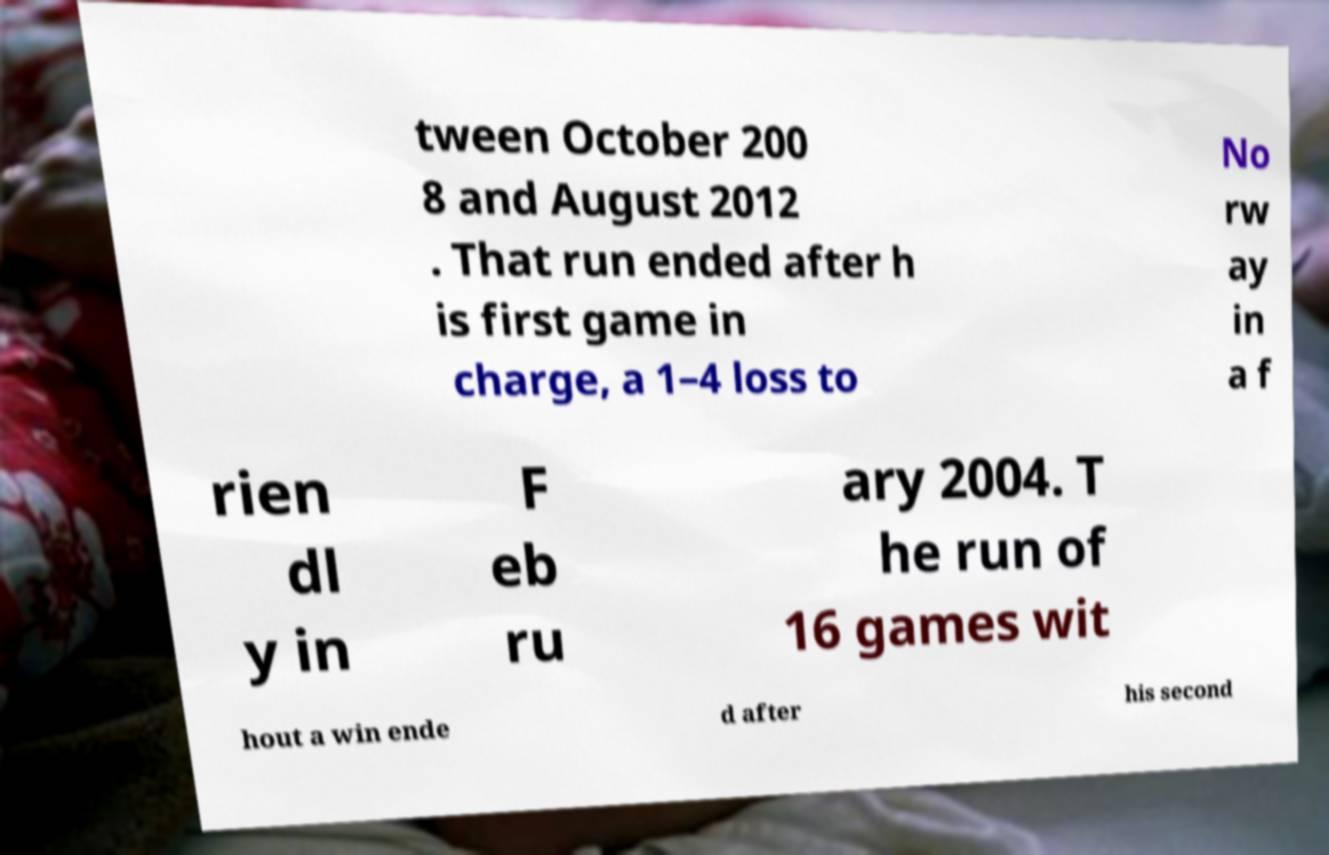Can you accurately transcribe the text from the provided image for me? tween October 200 8 and August 2012 . That run ended after h is first game in charge, a 1–4 loss to No rw ay in a f rien dl y in F eb ru ary 2004. T he run of 16 games wit hout a win ende d after his second 